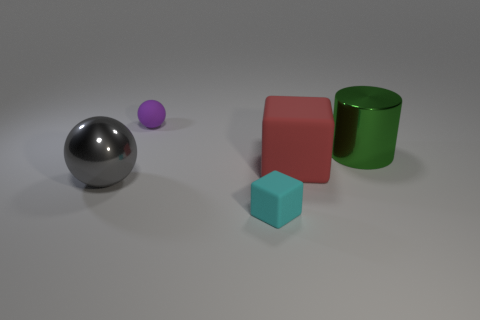Can you tell me the colors of the objects in the image? Certainly! From left to right, the colors of the objects are silver, violet, red, teal, and green. And which one would you say is the smallest? The smallest object is the violet sphere located to the left of the silver sphere. 